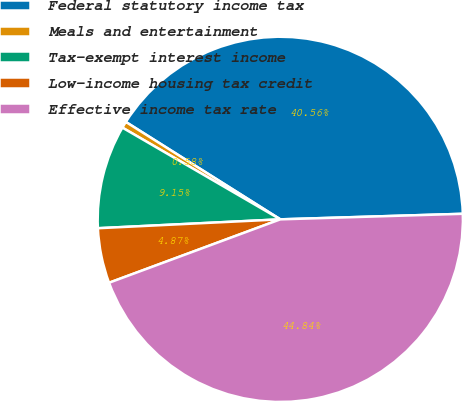Convert chart to OTSL. <chart><loc_0><loc_0><loc_500><loc_500><pie_chart><fcel>Federal statutory income tax<fcel>Meals and entertainment<fcel>Tax-exempt interest income<fcel>Low-income housing tax credit<fcel>Effective income tax rate<nl><fcel>40.56%<fcel>0.58%<fcel>9.15%<fcel>4.87%<fcel>44.84%<nl></chart> 